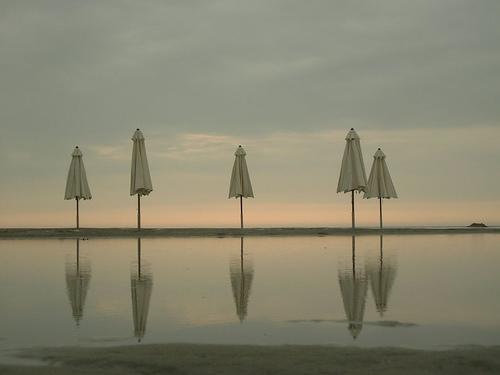How many umbrellas?
Give a very brief answer. 5. 